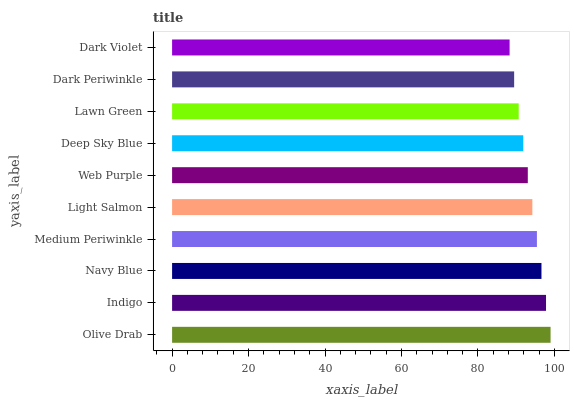Is Dark Violet the minimum?
Answer yes or no. Yes. Is Olive Drab the maximum?
Answer yes or no. Yes. Is Indigo the minimum?
Answer yes or no. No. Is Indigo the maximum?
Answer yes or no. No. Is Olive Drab greater than Indigo?
Answer yes or no. Yes. Is Indigo less than Olive Drab?
Answer yes or no. Yes. Is Indigo greater than Olive Drab?
Answer yes or no. No. Is Olive Drab less than Indigo?
Answer yes or no. No. Is Light Salmon the high median?
Answer yes or no. Yes. Is Web Purple the low median?
Answer yes or no. Yes. Is Lawn Green the high median?
Answer yes or no. No. Is Indigo the low median?
Answer yes or no. No. 